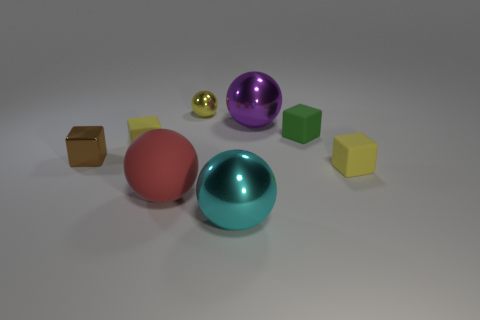What is the small yellow cube that is to the right of the big red object made of?
Your answer should be very brief. Rubber. Is the number of large yellow metal cubes greater than the number of purple shiny spheres?
Keep it short and to the point. No. What number of things are tiny shiny objects right of the red rubber ball or large purple metal spheres?
Your response must be concise. 2. What number of small yellow blocks are behind the yellow block in front of the shiny cube?
Provide a succinct answer. 1. What size is the yellow block that is left of the tiny yellow rubber cube on the right side of the small matte object that is on the left side of the matte ball?
Provide a short and direct response. Small. There is a large shiny object that is right of the cyan thing; is it the same color as the big matte sphere?
Provide a short and direct response. No. What is the size of the yellow object that is the same shape as the large purple object?
Keep it short and to the point. Small. How many things are either red matte spheres that are in front of the purple thing or cyan spheres that are on the right side of the large red ball?
Your response must be concise. 2. The yellow rubber object left of the tiny yellow thing in front of the metallic cube is what shape?
Your answer should be very brief. Cube. Is there anything else that has the same color as the small shiny ball?
Your answer should be compact. Yes. 